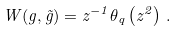Convert formula to latex. <formula><loc_0><loc_0><loc_500><loc_500>W ( g , \tilde { g } ) = z ^ { - 1 } \theta _ { q } \left ( z ^ { 2 } \right ) \, .</formula> 